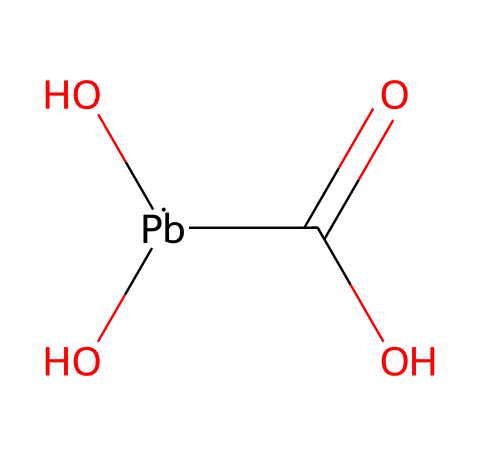What is the total number of oxygen atoms in this compound? By analyzing the SMILES representation, we see the notation "(O)(O)" indicates two oxygen atoms attached to lead (Pb), and there is also one oxygen atom in the "C(=O)" part of the carboxylic acid (-COOH) group. Therefore, there are a total of three oxygen atoms.
Answer: three How many carbon atoms are present in this structure? In the SMILES representation, "C(=O)" indicates one carbon atom that is part of a carboxylic acid group (-COOH), and there are no other carbon atoms present in the structure. Thus, there is only one carbon atom in total.
Answer: one What is the valency of lead in this compound? Lead typically has a valency of four in its compounds, as indicated by its tetravalent nature when bonded to the two hydroxyl groups (O) and the carbonyl group (C=O) in this case.
Answer: four What type of functional group is presented in the structure? The structure contains a carboxylic acid functional group, as demonstrated by the presence of the -COOH (inferred from C(=O)O) section of the compound. This group characterizes the compound as a lead salt of a carboxylic acid.
Answer: carboxylic acid Does this compound contain any hydrogen atoms? The carboxylic acid functional group (-COOH) indicates the presence of one hydrogen atom, and the two hydroxyl groups (O) each can also be bonded to one additional hydrogen atom if seen as -OH groups. This confirms the presence of three hydrogen atoms in total.
Answer: three 